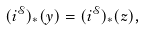<formula> <loc_0><loc_0><loc_500><loc_500>( i ^ { \mathcal { S } } ) _ { * } ( y ) = ( i ^ { \mathcal { S } } ) _ { * } ( z ) ,</formula> 